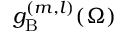Convert formula to latex. <formula><loc_0><loc_0><loc_500><loc_500>g _ { B } ^ { ( m , l ) } ( \Omega )</formula> 